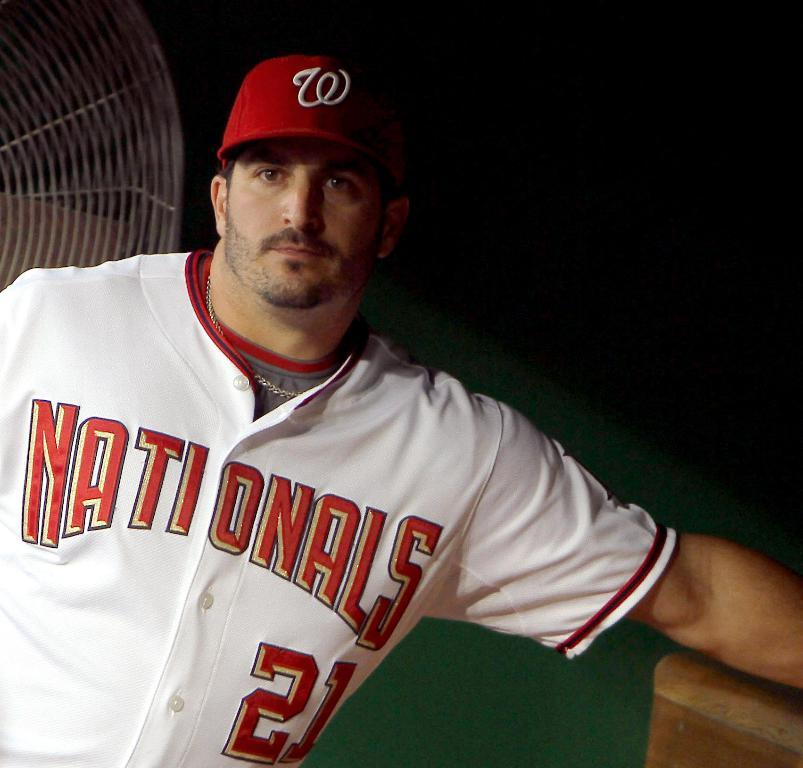<image>
Summarize the visual content of the image. A baseball player wearing the Nationals jersey and number 21 